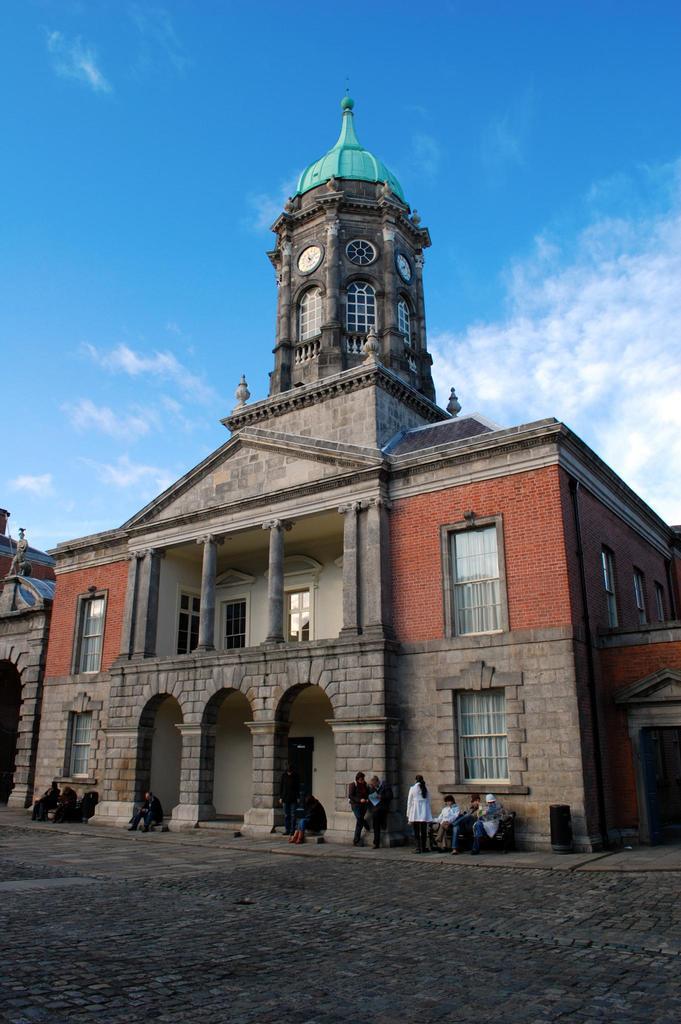In one or two sentences, can you explain what this image depicts? In this image, we can see a building with brick walls, glass windows, pillars. Here we can see few clocks on the wall. At the bottom, a group of people are there. Few are sitting and standing. Here we can see a platform. Background there is a sky. 